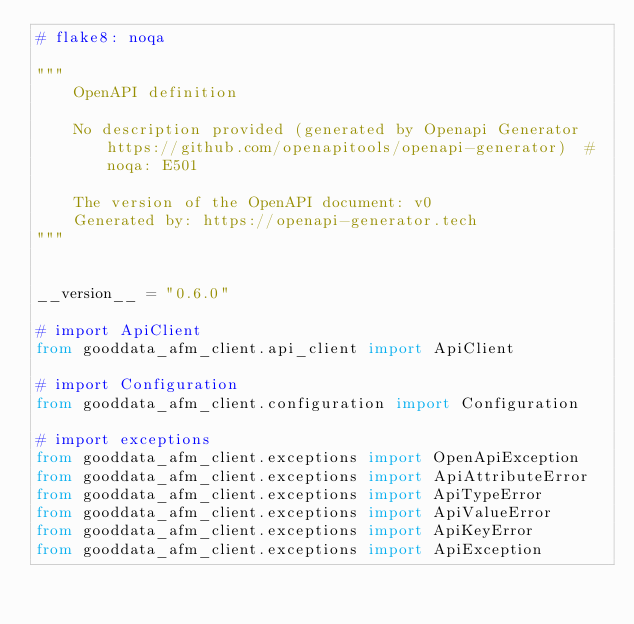Convert code to text. <code><loc_0><loc_0><loc_500><loc_500><_Python_># flake8: noqa

"""
    OpenAPI definition

    No description provided (generated by Openapi Generator https://github.com/openapitools/openapi-generator)  # noqa: E501

    The version of the OpenAPI document: v0
    Generated by: https://openapi-generator.tech
"""


__version__ = "0.6.0"

# import ApiClient
from gooddata_afm_client.api_client import ApiClient

# import Configuration
from gooddata_afm_client.configuration import Configuration

# import exceptions
from gooddata_afm_client.exceptions import OpenApiException
from gooddata_afm_client.exceptions import ApiAttributeError
from gooddata_afm_client.exceptions import ApiTypeError
from gooddata_afm_client.exceptions import ApiValueError
from gooddata_afm_client.exceptions import ApiKeyError
from gooddata_afm_client.exceptions import ApiException
</code> 